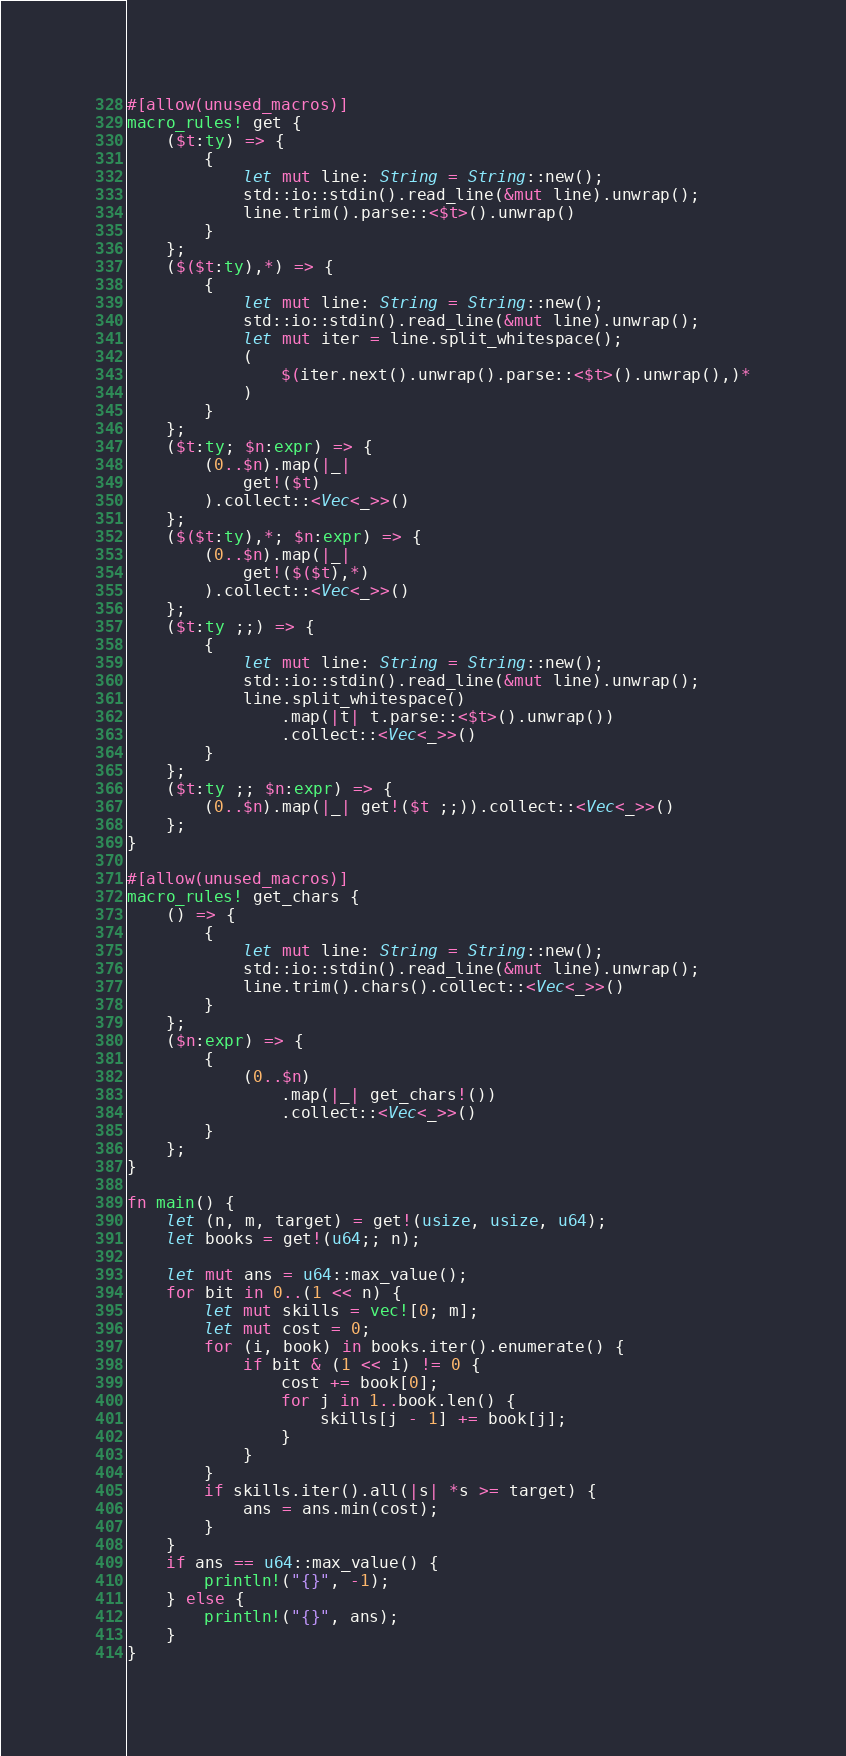Convert code to text. <code><loc_0><loc_0><loc_500><loc_500><_Rust_>#[allow(unused_macros)]
macro_rules! get {
    ($t:ty) => {
        {
            let mut line: String = String::new();
            std::io::stdin().read_line(&mut line).unwrap();
            line.trim().parse::<$t>().unwrap()
        }
    };
    ($($t:ty),*) => {
        {
            let mut line: String = String::new();
            std::io::stdin().read_line(&mut line).unwrap();
            let mut iter = line.split_whitespace();
            (
                $(iter.next().unwrap().parse::<$t>().unwrap(),)*
            )
        }
    };
    ($t:ty; $n:expr) => {
        (0..$n).map(|_|
            get!($t)
        ).collect::<Vec<_>>()
    };
    ($($t:ty),*; $n:expr) => {
        (0..$n).map(|_|
            get!($($t),*)
        ).collect::<Vec<_>>()
    };
    ($t:ty ;;) => {
        {
            let mut line: String = String::new();
            std::io::stdin().read_line(&mut line).unwrap();
            line.split_whitespace()
                .map(|t| t.parse::<$t>().unwrap())
                .collect::<Vec<_>>()
        }
    };
    ($t:ty ;; $n:expr) => {
        (0..$n).map(|_| get!($t ;;)).collect::<Vec<_>>()
    };
}

#[allow(unused_macros)]
macro_rules! get_chars {
    () => {
        {
            let mut line: String = String::new();
            std::io::stdin().read_line(&mut line).unwrap();
            line.trim().chars().collect::<Vec<_>>()
        }
    };
    ($n:expr) => {
        {
            (0..$n)
                .map(|_| get_chars!())
                .collect::<Vec<_>>()
        }
    };
}

fn main() {
    let (n, m, target) = get!(usize, usize, u64);
    let books = get!(u64;; n);

    let mut ans = u64::max_value();
    for bit in 0..(1 << n) {
        let mut skills = vec![0; m];
        let mut cost = 0;
        for (i, book) in books.iter().enumerate() {
            if bit & (1 << i) != 0 {
                cost += book[0];
                for j in 1..book.len() {
                    skills[j - 1] += book[j];
                }
            }
        }
        if skills.iter().all(|s| *s >= target) {
            ans = ans.min(cost);
        }
    }
    if ans == u64::max_value() {
        println!("{}", -1);
    } else {
        println!("{}", ans);
    }
}
</code> 